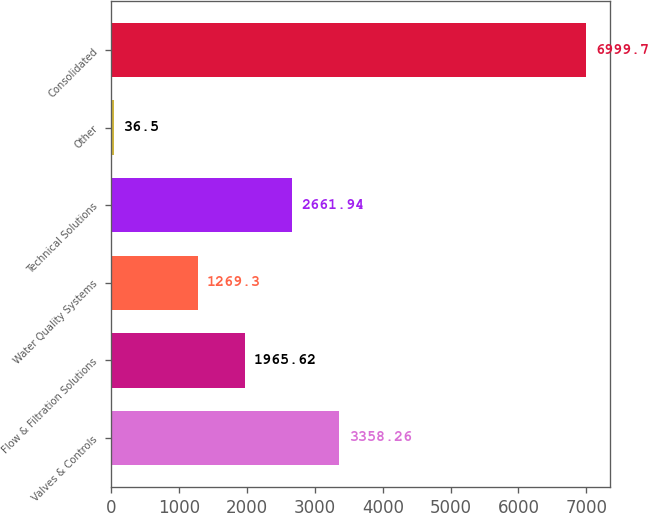<chart> <loc_0><loc_0><loc_500><loc_500><bar_chart><fcel>Valves & Controls<fcel>Flow & Filtration Solutions<fcel>Water Quality Systems<fcel>Technical Solutions<fcel>Other<fcel>Consolidated<nl><fcel>3358.26<fcel>1965.62<fcel>1269.3<fcel>2661.94<fcel>36.5<fcel>6999.7<nl></chart> 